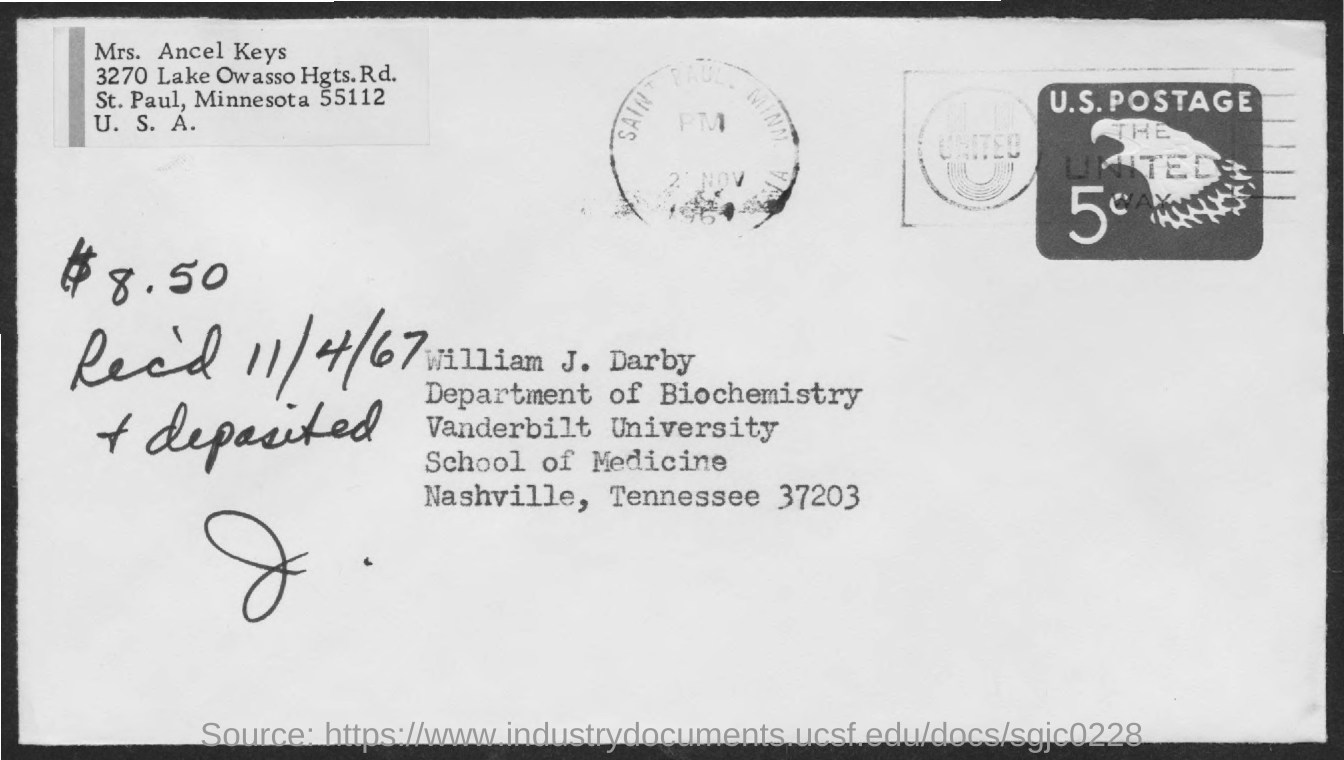What is the received date mentioned in the postal card?
Offer a very short reply. 11/4/67. What is the amount deposited?
Your answer should be very brief. 8.50. Who's from the vanderbilt university as given in the address?
Make the answer very short. William J. Darby. 